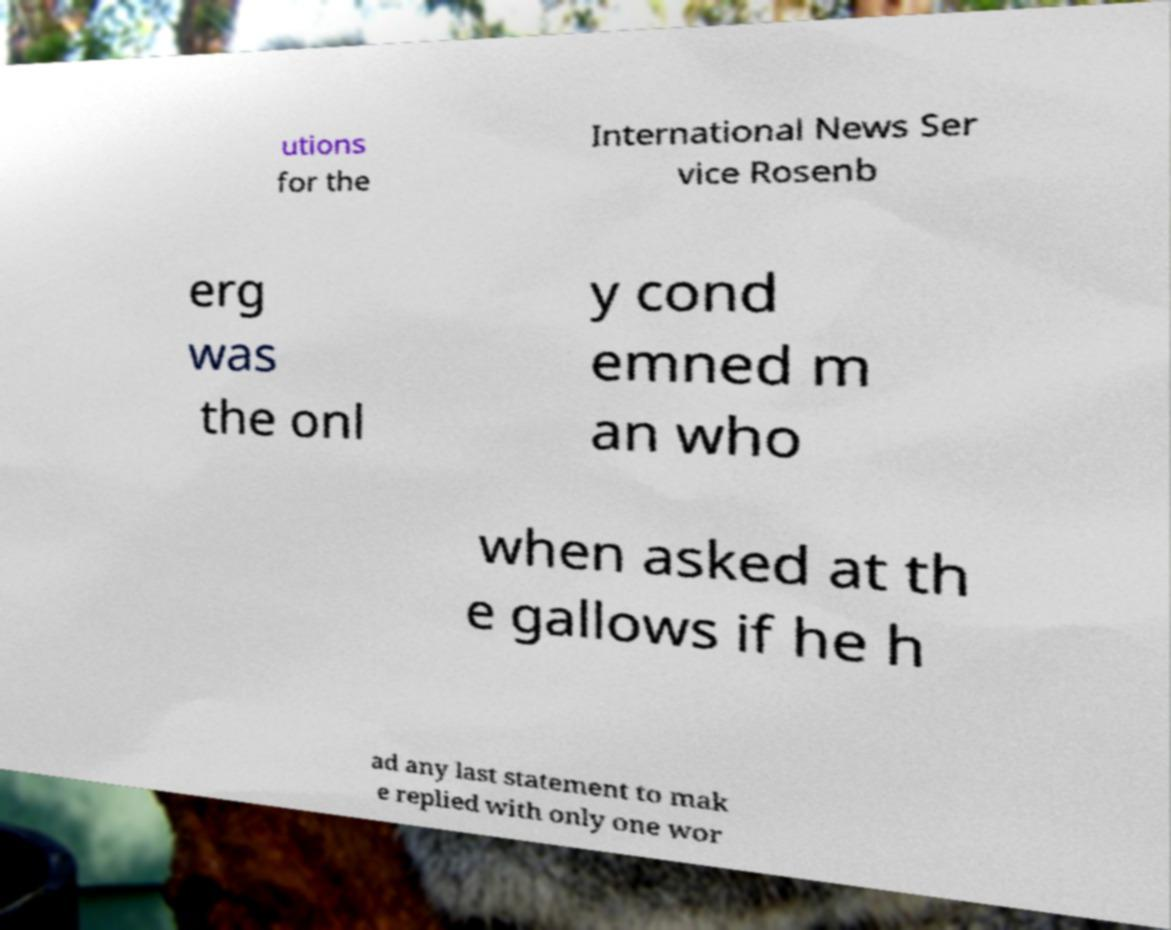There's text embedded in this image that I need extracted. Can you transcribe it verbatim? utions for the International News Ser vice Rosenb erg was the onl y cond emned m an who when asked at th e gallows if he h ad any last statement to mak e replied with only one wor 